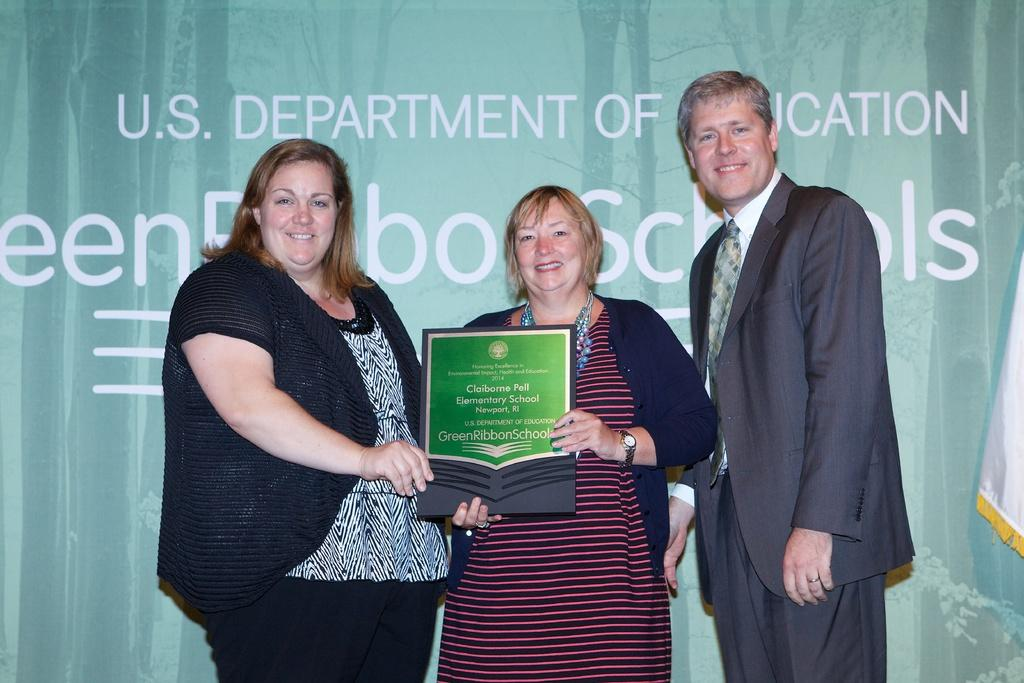What is the gender of the person in the image? There is a man in the image. How many women are present in the image? There are 2 women in the image. What are the man and women holding in the image? The man and women are holding something, but the facts do not specify what they are holding. What expressions do the man and women have in the image? The man and women are smiling in the image. Who might the man and women be smiling at? They appear to be smiling at someone, but the facts do not specify who that person might be. How many rabbits can be seen hopping around in the image? There are no rabbits present in the image. What type of squirrel can be seen climbing up the tree in the image? There is no tree or squirrel present in the image. 